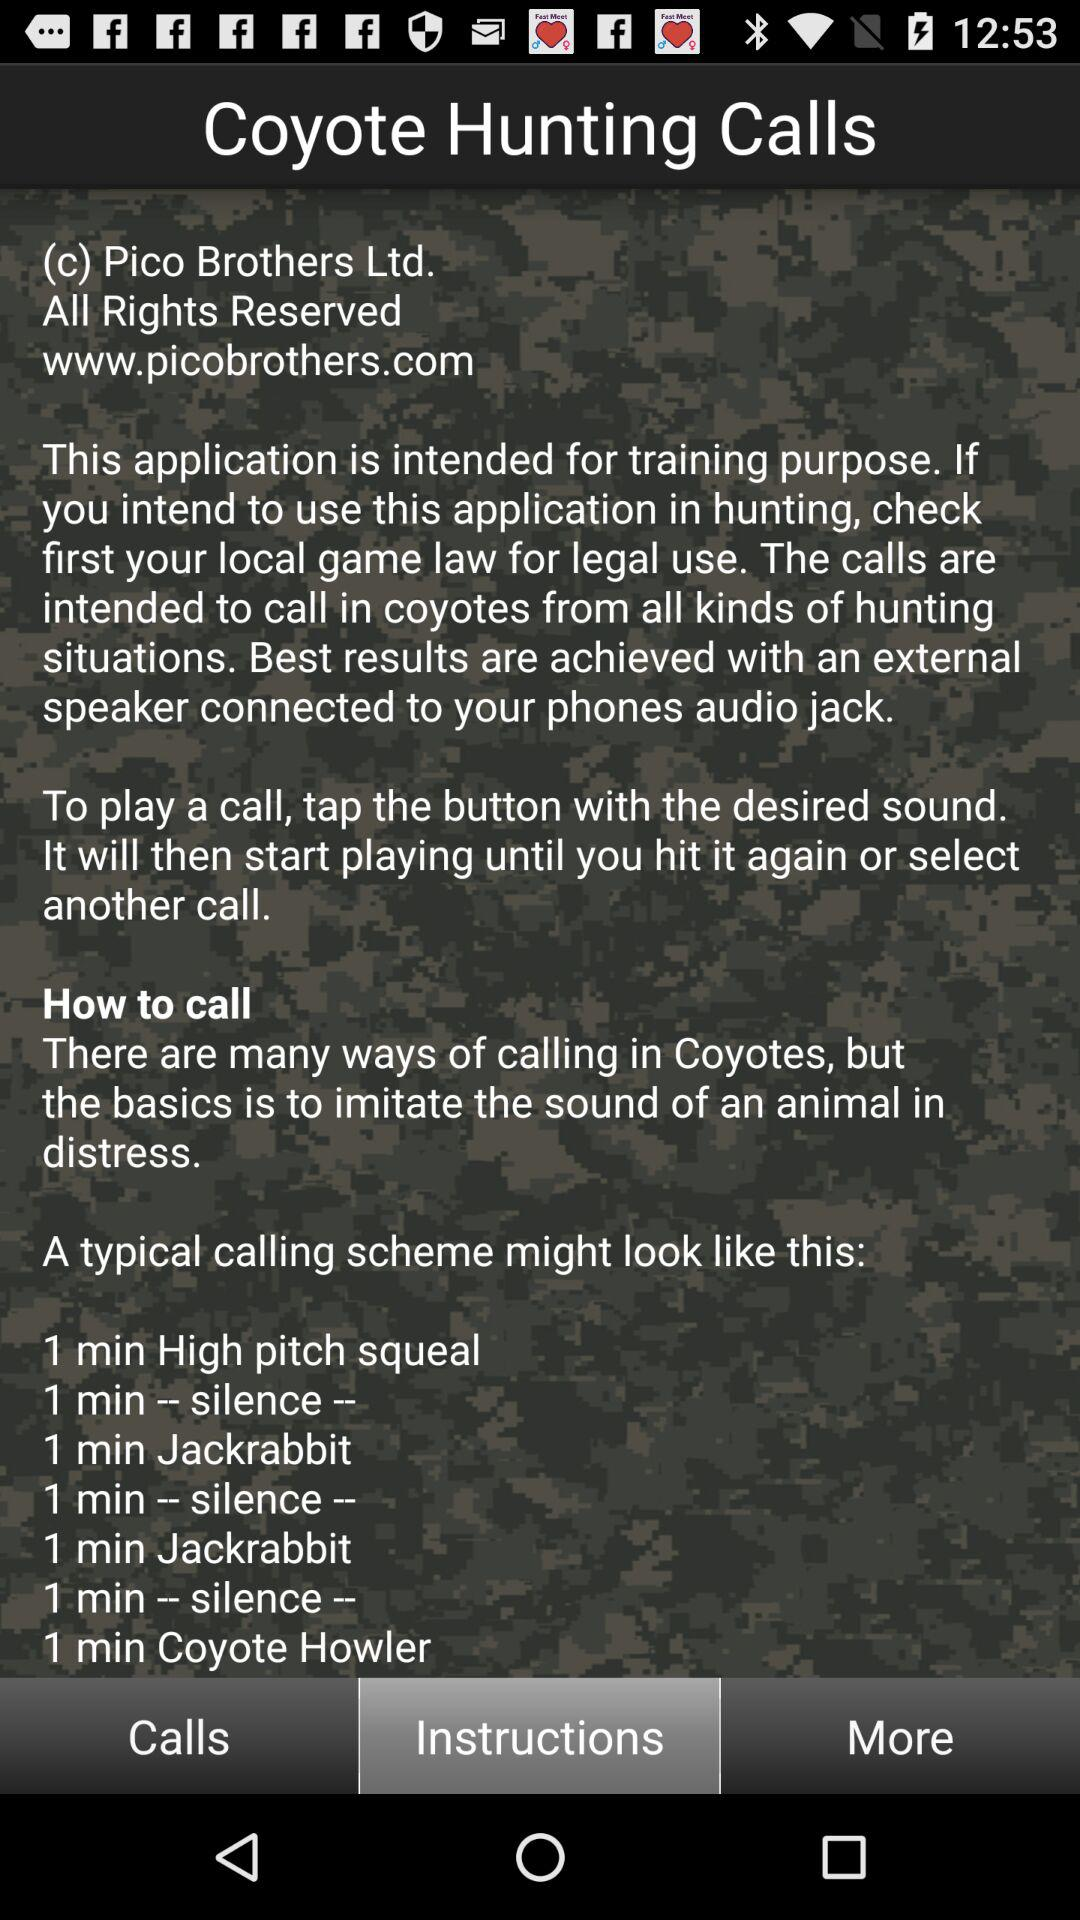Could you explain what the coyote howler mentioned in the instructions is used for? The 'Coyote Howler' mentioned is a type of hunting call designed to mimic the howls of a coyote. This can be effective in attracting coyotes by either capitalizing on their territorial instincts or curiosity about the presence of other coyotes. 